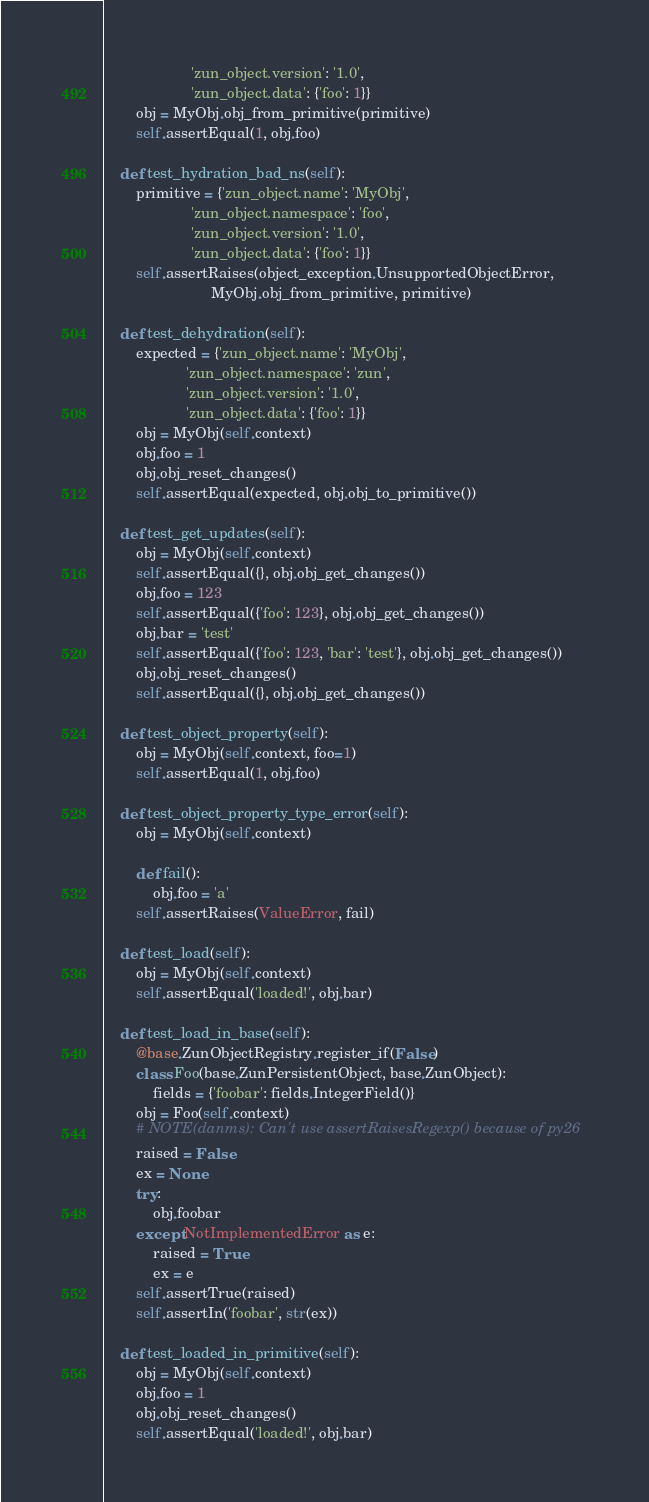<code> <loc_0><loc_0><loc_500><loc_500><_Python_>                     'zun_object.version': '1.0',
                     'zun_object.data': {'foo': 1}}
        obj = MyObj.obj_from_primitive(primitive)
        self.assertEqual(1, obj.foo)

    def test_hydration_bad_ns(self):
        primitive = {'zun_object.name': 'MyObj',
                     'zun_object.namespace': 'foo',
                     'zun_object.version': '1.0',
                     'zun_object.data': {'foo': 1}}
        self.assertRaises(object_exception.UnsupportedObjectError,
                          MyObj.obj_from_primitive, primitive)

    def test_dehydration(self):
        expected = {'zun_object.name': 'MyObj',
                    'zun_object.namespace': 'zun',
                    'zun_object.version': '1.0',
                    'zun_object.data': {'foo': 1}}
        obj = MyObj(self.context)
        obj.foo = 1
        obj.obj_reset_changes()
        self.assertEqual(expected, obj.obj_to_primitive())

    def test_get_updates(self):
        obj = MyObj(self.context)
        self.assertEqual({}, obj.obj_get_changes())
        obj.foo = 123
        self.assertEqual({'foo': 123}, obj.obj_get_changes())
        obj.bar = 'test'
        self.assertEqual({'foo': 123, 'bar': 'test'}, obj.obj_get_changes())
        obj.obj_reset_changes()
        self.assertEqual({}, obj.obj_get_changes())

    def test_object_property(self):
        obj = MyObj(self.context, foo=1)
        self.assertEqual(1, obj.foo)

    def test_object_property_type_error(self):
        obj = MyObj(self.context)

        def fail():
            obj.foo = 'a'
        self.assertRaises(ValueError, fail)

    def test_load(self):
        obj = MyObj(self.context)
        self.assertEqual('loaded!', obj.bar)

    def test_load_in_base(self):
        @base.ZunObjectRegistry.register_if(False)
        class Foo(base.ZunPersistentObject, base.ZunObject):
            fields = {'foobar': fields.IntegerField()}
        obj = Foo(self.context)
        # NOTE(danms): Can't use assertRaisesRegexp() because of py26
        raised = False
        ex = None
        try:
            obj.foobar
        except NotImplementedError as e:
            raised = True
            ex = e
        self.assertTrue(raised)
        self.assertIn('foobar', str(ex))

    def test_loaded_in_primitive(self):
        obj = MyObj(self.context)
        obj.foo = 1
        obj.obj_reset_changes()
        self.assertEqual('loaded!', obj.bar)</code> 